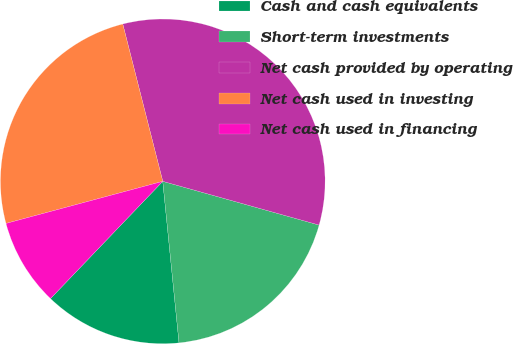<chart> <loc_0><loc_0><loc_500><loc_500><pie_chart><fcel>Cash and cash equivalents<fcel>Short-term investments<fcel>Net cash provided by operating<fcel>Net cash used in investing<fcel>Net cash used in financing<nl><fcel>13.75%<fcel>19.06%<fcel>33.3%<fcel>25.21%<fcel>8.67%<nl></chart> 